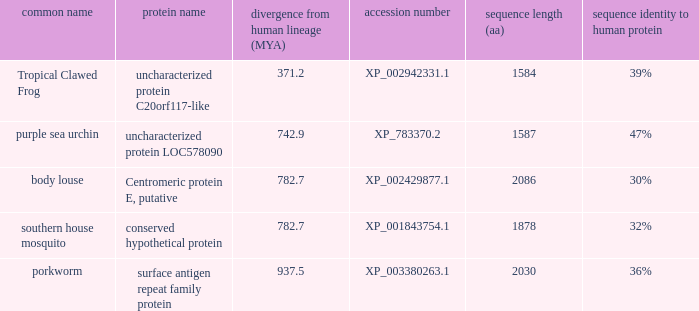What is the protein name of the protein with a sequence identity to human protein of 32%? Conserved hypothetical protein. 